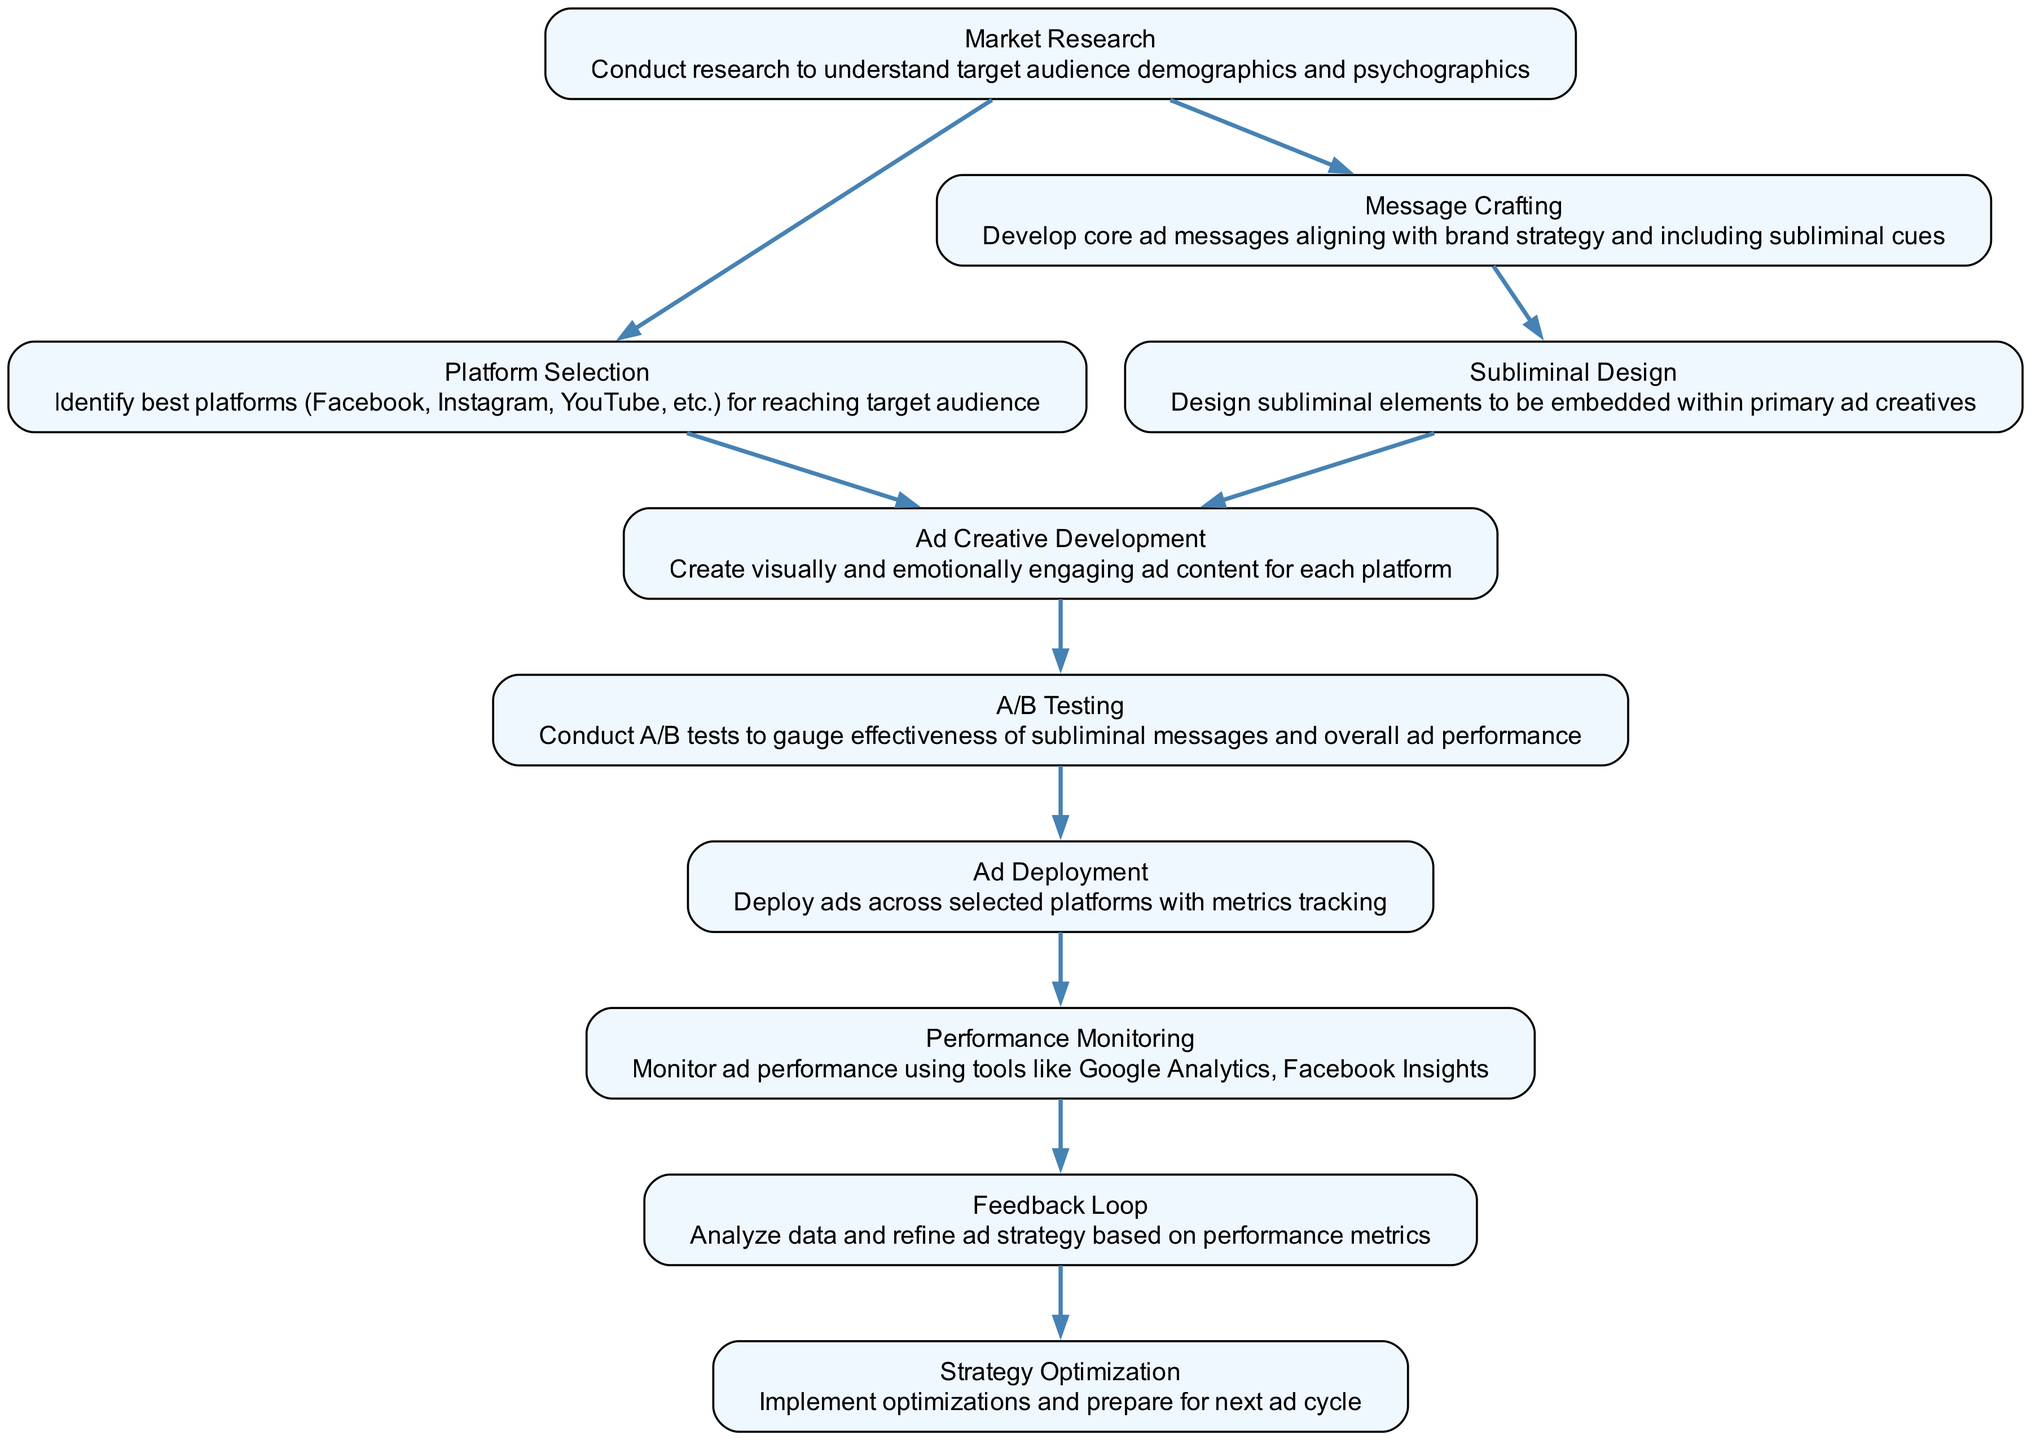What is the first step in the strategy? The first step listed in the flow chart is "Market Research," which has no dependencies, indicating it should be conducted first.
Answer: Market Research Which task depends on "Message Crafting"? The task that depends on "Message Crafting" is "Subliminal Design," showing that designing the subliminal elements requires crafting the core ad messages first.
Answer: Subliminal Design How many nodes are in the diagram? By counting the number of unique tasks listed in the elements of the flow chart, we find there are a total of 10 nodes within the diagram.
Answer: 10 What are the last steps after "Performance Monitoring"? The step that follows "Performance Monitoring" is "Feedback Loop," which indicates that performance monitoring leads directly to feedback analysis for strategy refinement.
Answer: Feedback Loop Which platforms can be selected according to the diagram? According to the diagram, platforms like Facebook, Instagram, and YouTube can be selected, as specified in the description of "Platform Selection."
Answer: Facebook, Instagram, YouTube Which step requires A/B Testing to proceed? The step that requires "A/B Testing" to be completed before it can proceed is "Ad Deployment," highlighting that testing effectiveness is crucial before launching the ads.
Answer: Ad Deployment What type of analysis is performed in the "Feedback Loop"? The analysis performed in the "Feedback Loop" involves analyzing data to refine the ad strategy based on the collected performance metrics from earlier steps.
Answer: Analyze data What node follows "Ad Creative Development"? The node that follows "Ad Creative Development" is "A/B Testing," indicating that after creating the ad content, it is important to conduct testing for effectiveness.
Answer: A/B Testing What is the main goal of "Strategy Optimization"? The main goal of "Strategy Optimization" is to implement optimizations for improvement and prepare everything for the next ad cycle, focusing on continual enhancement.
Answer: Implement optimizations 